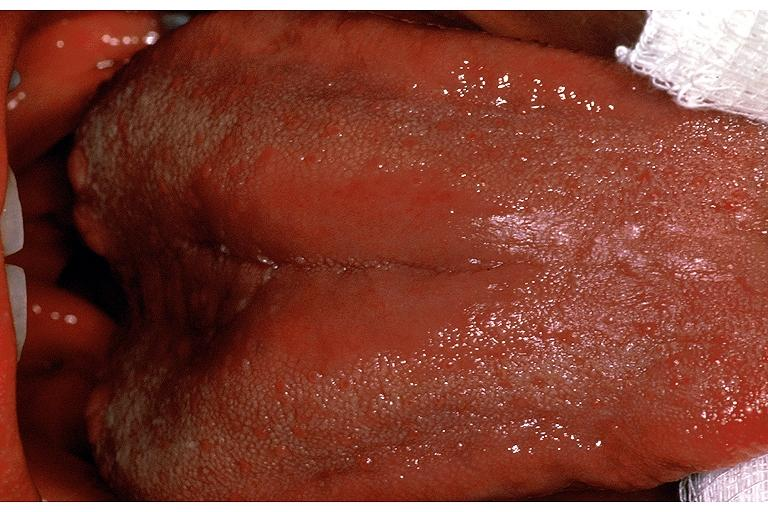what is present?
Answer the question using a single word or phrase. Oral 